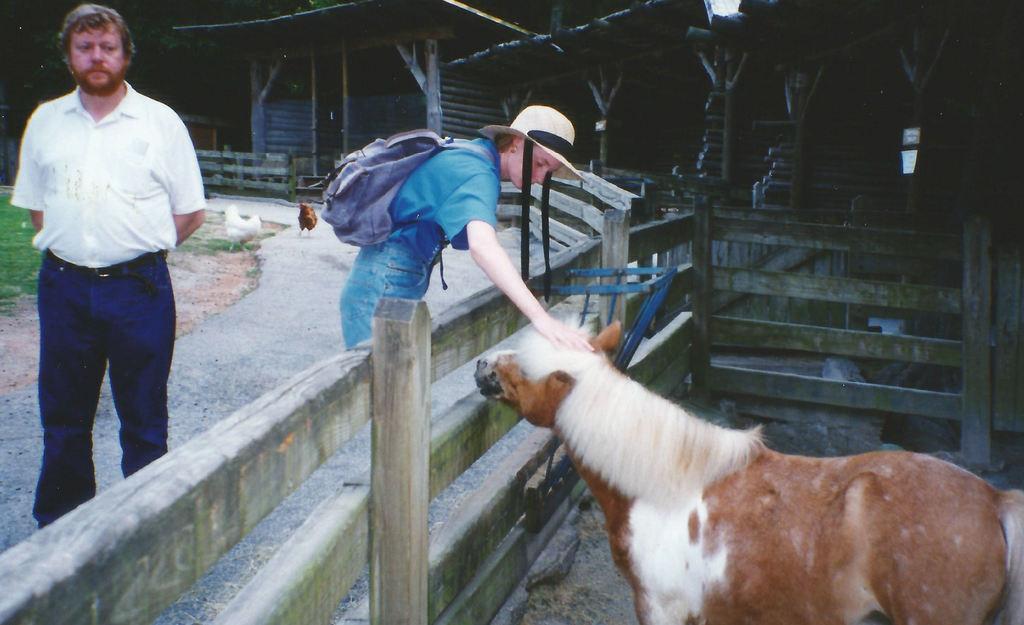Describe this image in one or two sentences. In this picture I can see there is a woman wearing a cap and a bag. There is a horse at right side and there is a wooden fence around it. There is a man standing at the left side, there are hens in the backdrop and there are wooden houses at the right side. 